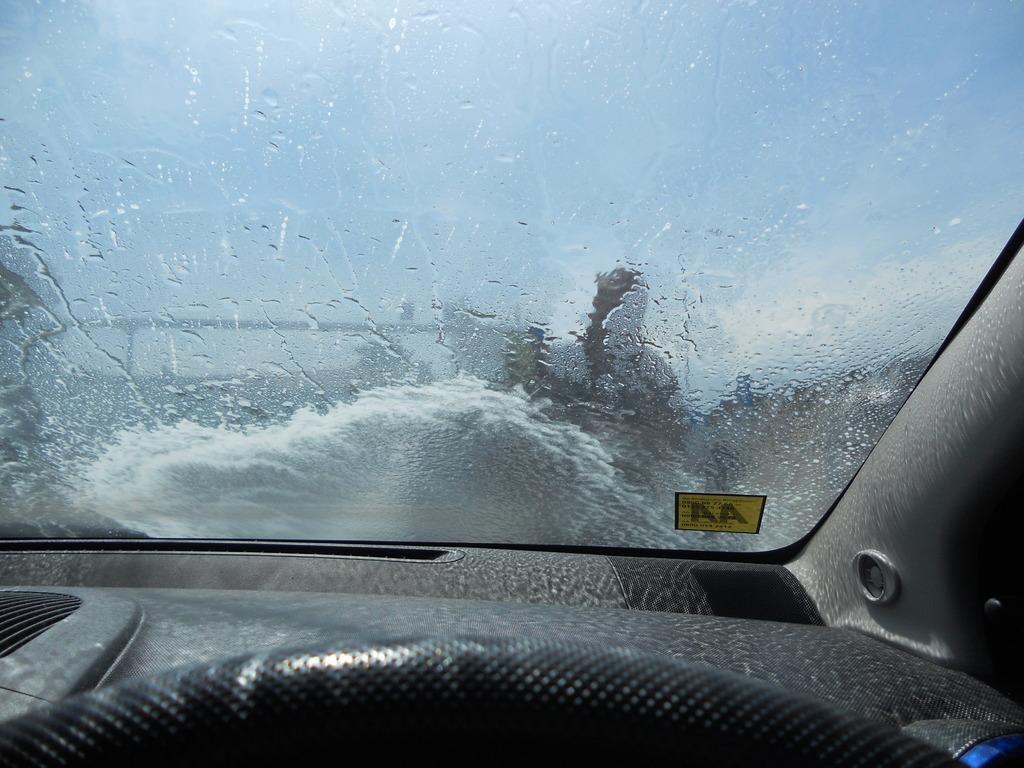Could you give a brief overview of what you see in this image? This is a inside view of a car, where we can see windshield, dashboard, steering. 